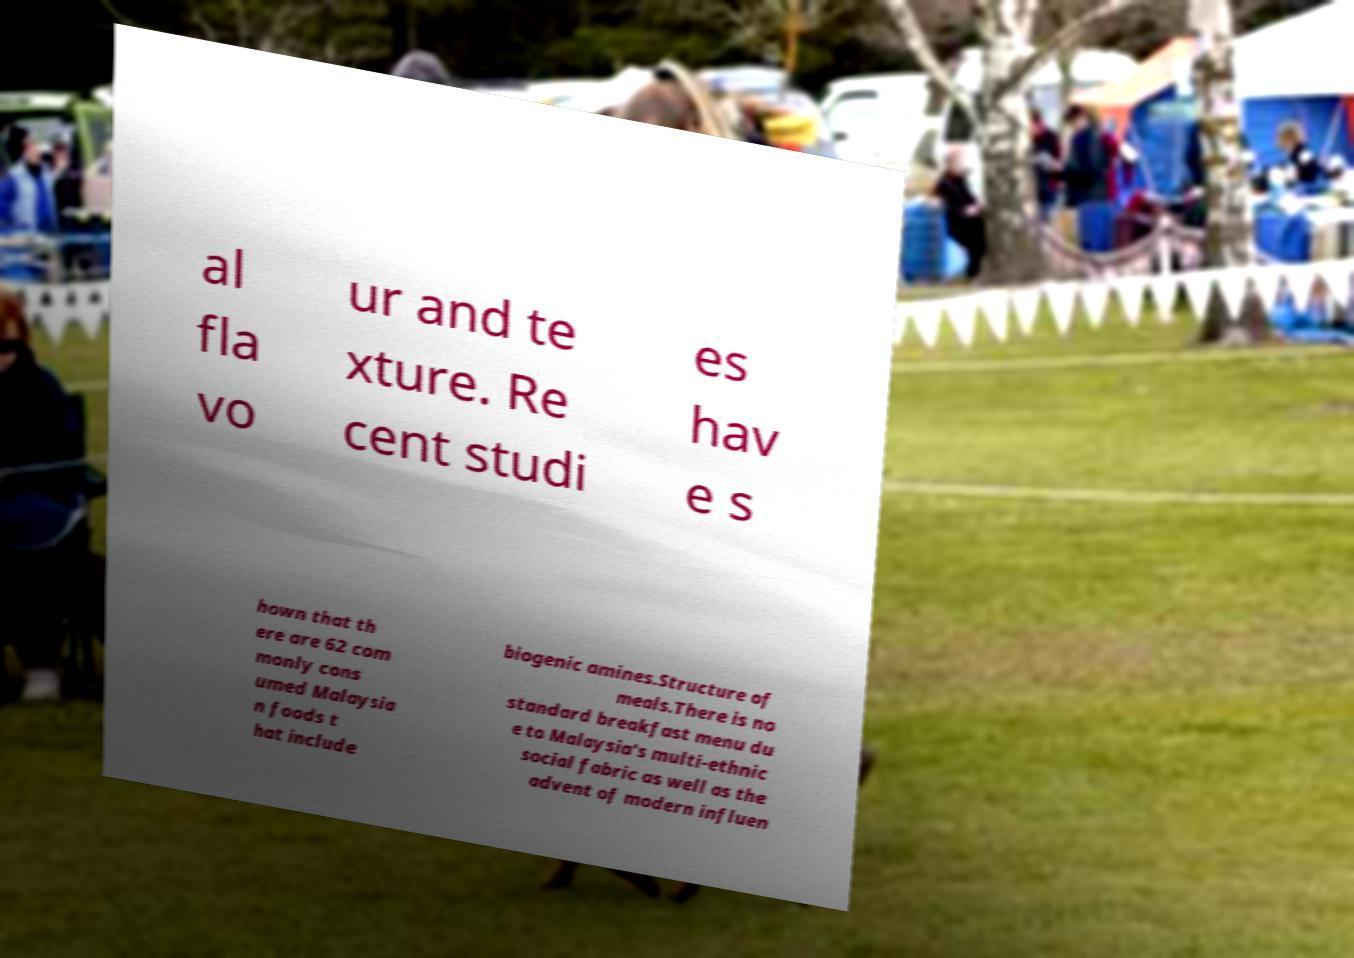For documentation purposes, I need the text within this image transcribed. Could you provide that? al fla vo ur and te xture. Re cent studi es hav e s hown that th ere are 62 com monly cons umed Malaysia n foods t hat include biogenic amines.Structure of meals.There is no standard breakfast menu du e to Malaysia's multi-ethnic social fabric as well as the advent of modern influen 